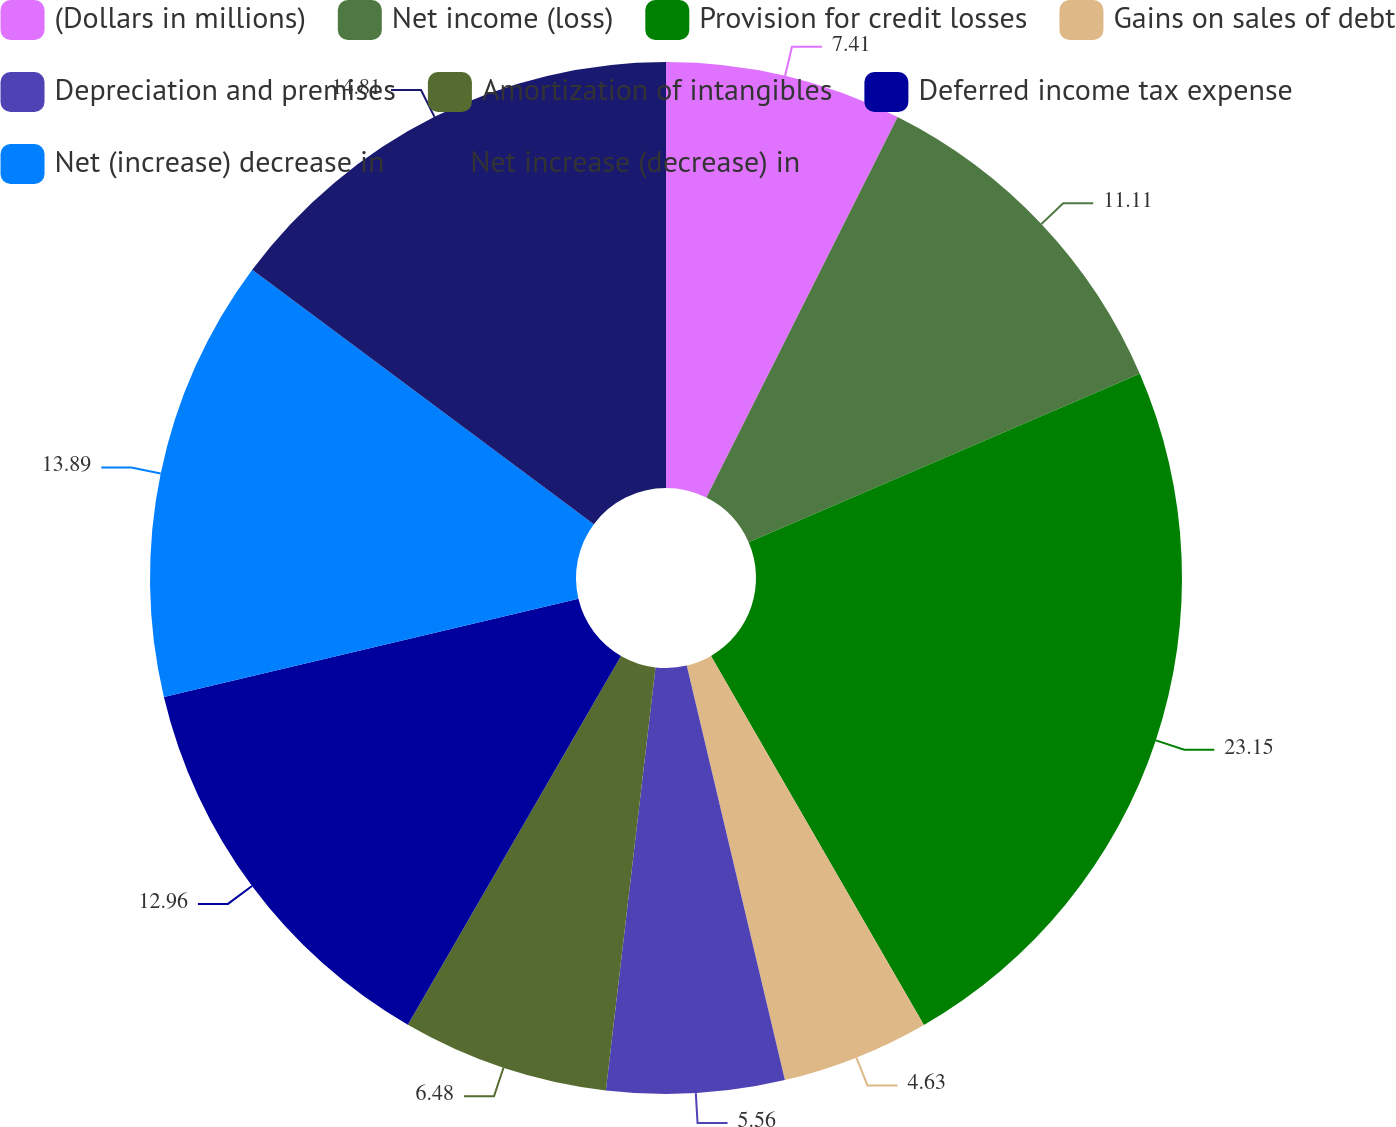<chart> <loc_0><loc_0><loc_500><loc_500><pie_chart><fcel>(Dollars in millions)<fcel>Net income (loss)<fcel>Provision for credit losses<fcel>Gains on sales of debt<fcel>Depreciation and premises<fcel>Amortization of intangibles<fcel>Deferred income tax expense<fcel>Net (increase) decrease in<fcel>Net increase (decrease) in<nl><fcel>7.41%<fcel>11.11%<fcel>23.15%<fcel>4.63%<fcel>5.56%<fcel>6.48%<fcel>12.96%<fcel>13.89%<fcel>14.81%<nl></chart> 